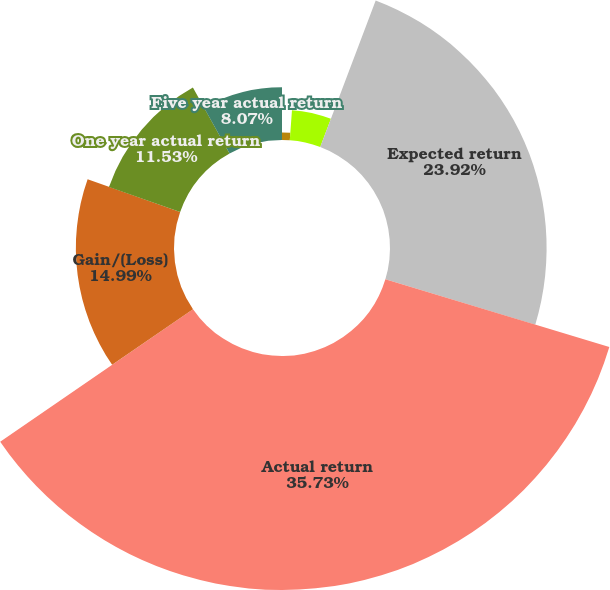<chart> <loc_0><loc_0><loc_500><loc_500><pie_chart><fcel>Weighted average discount rate<fcel>Expected rate of return<fcel>Expected return<fcel>Actual return<fcel>Gain/(Loss)<fcel>One year actual return<fcel>Five year actual return<nl><fcel>1.15%<fcel>4.61%<fcel>23.92%<fcel>35.74%<fcel>14.99%<fcel>11.53%<fcel>8.07%<nl></chart> 